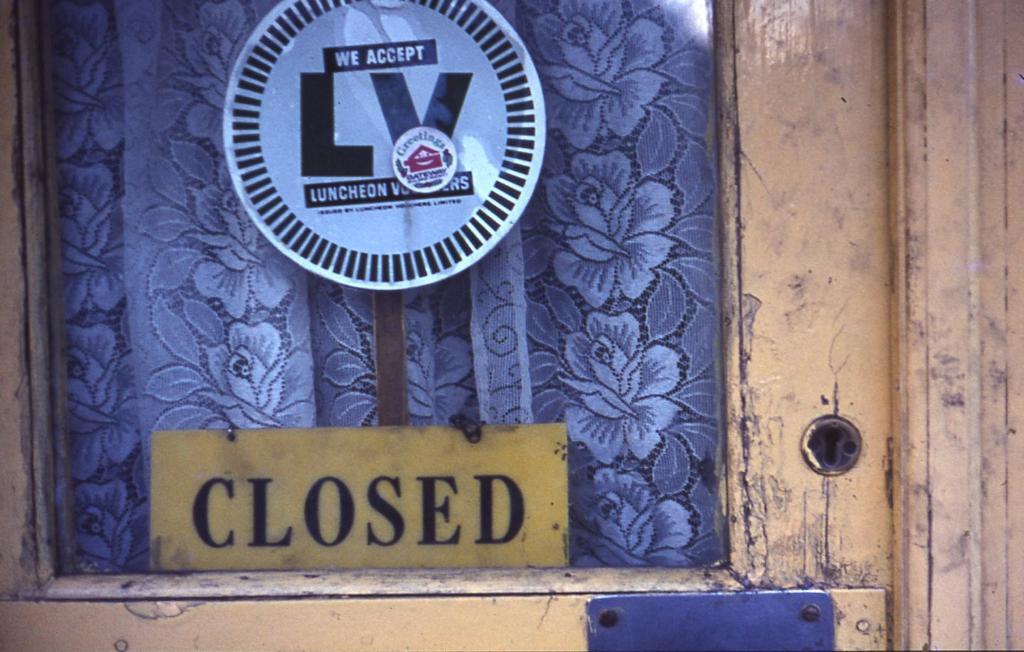Whats the sign telling?
Your answer should be compact. Closed. 